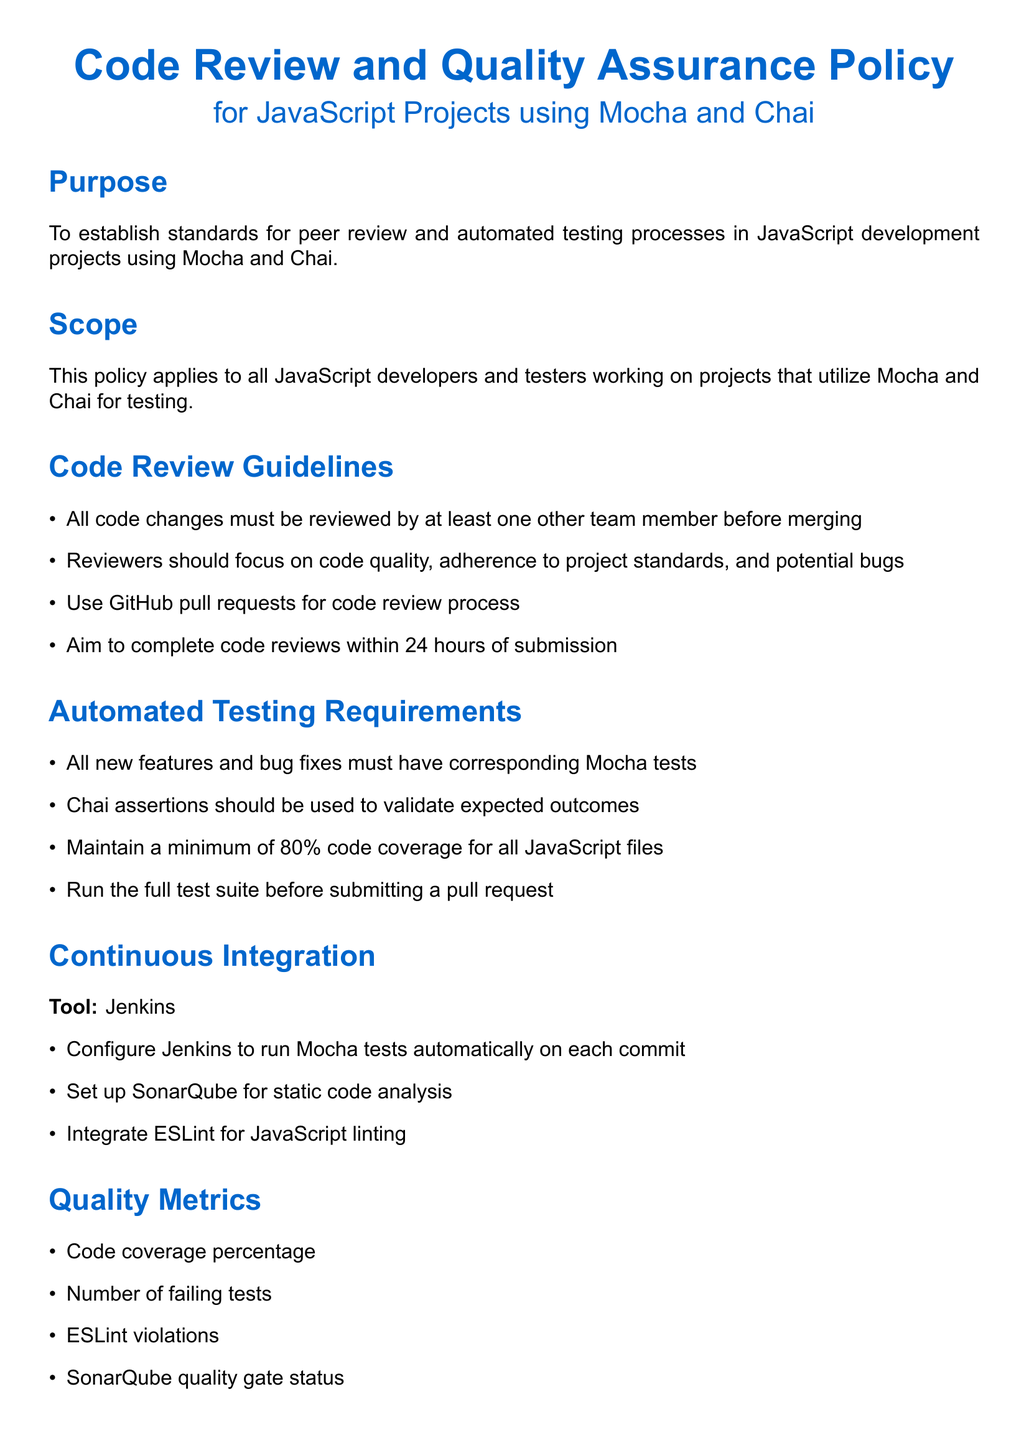What is the purpose of the policy? The purpose of the policy is to establish standards for peer review and automated testing processes in JavaScript development projects using Mocha and Chai.
Answer: To establish standards for peer review and automated testing processes What is the minimum code coverage required? The document specifies that there must be a minimum of 80 percent code coverage for all JavaScript files.
Answer: 80 percent How long should code reviews aim to be completed? The policy states that code reviews should be completed within 24 hours of submission.
Answer: 24 hours What tool is used for Continuous Integration? The document mentions Jenkins as the tool for Continuous Integration.
Answer: Jenkins Who is responsible for enforcing policy compliance? The Team Lead is identified as responsible for enforcing policy compliance.
Answer: Team Lead Which testing framework must be used for new features? The document requires using Mocha for new features and bug fixes.
Answer: Mocha What should be included in the code review process? The code review process should include the use of GitHub pull requests.
Answer: GitHub pull requests What should be created by testers? Testers are responsible for creating integration and end-to-end tests.
Answer: Integration and end-to-end tests What document is referenced for training resources? The internal wiki page titled "Best Practices for JavaScript Testing" is referenced for training resources.
Answer: Best Practices for JavaScript Testing 